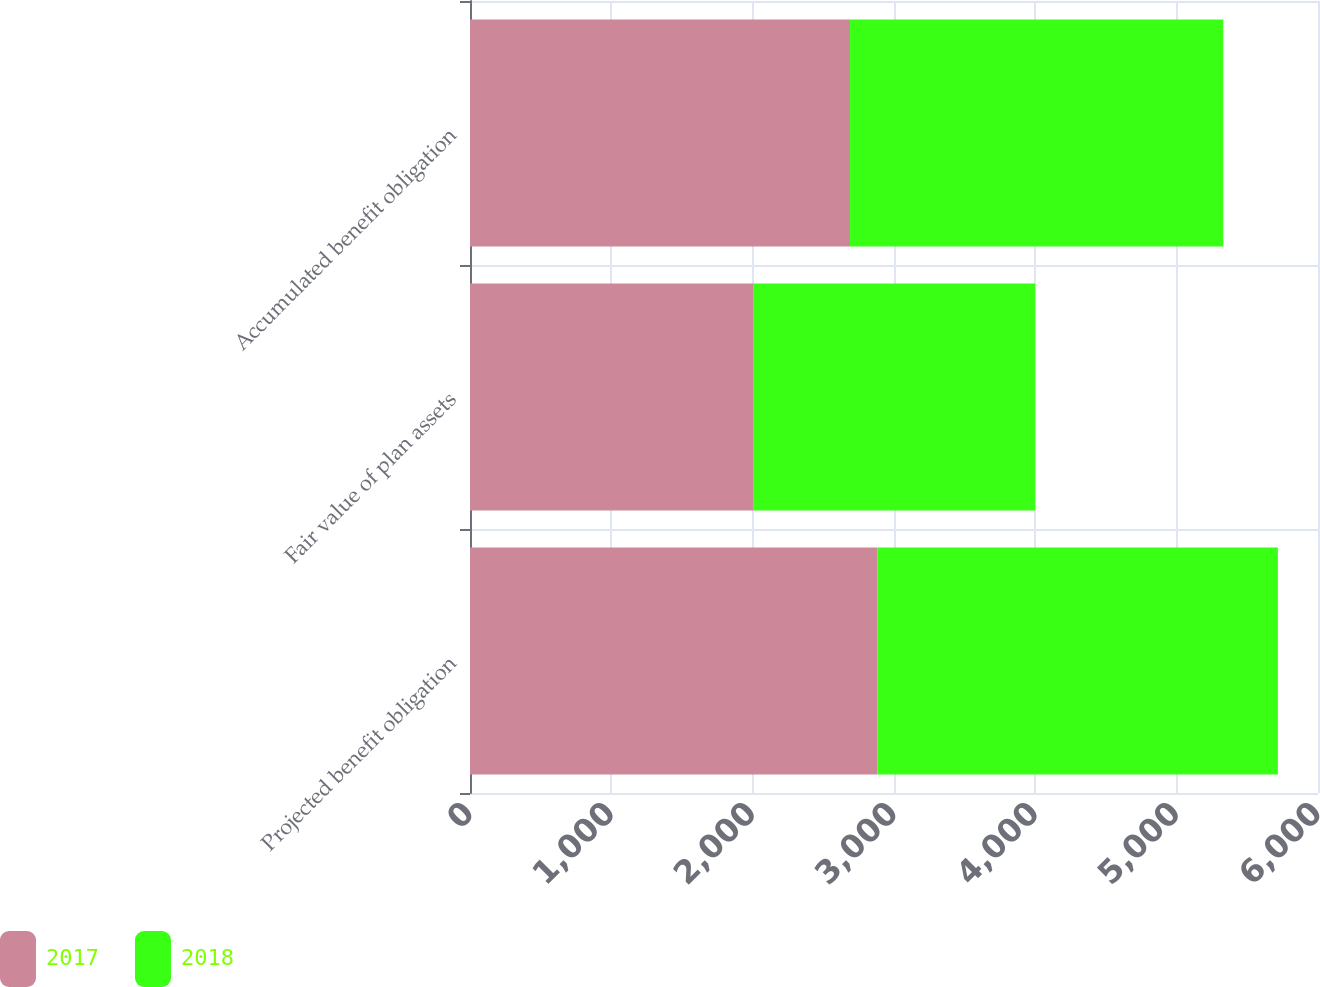Convert chart to OTSL. <chart><loc_0><loc_0><loc_500><loc_500><stacked_bar_chart><ecel><fcel>Projected benefit obligation<fcel>Fair value of plan assets<fcel>Accumulated benefit obligation<nl><fcel>2017<fcel>2882<fcel>2007<fcel>2689<nl><fcel>2018<fcel>2834<fcel>1992<fcel>2641<nl></chart> 